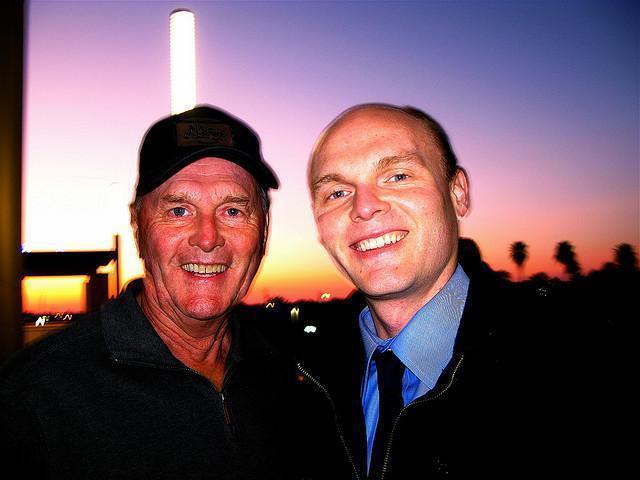How many people are wearing ties?
Give a very brief answer. 1. How many men are there in this picture?
Give a very brief answer. 2. How many people are in the photo?
Give a very brief answer. 2. How many buses are solid blue?
Give a very brief answer. 0. 